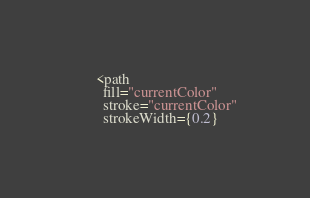Convert code to text. <code><loc_0><loc_0><loc_500><loc_500><_JavaScript_>      <path
        fill="currentColor"
        stroke="currentColor"
        strokeWidth={0.2}</code> 